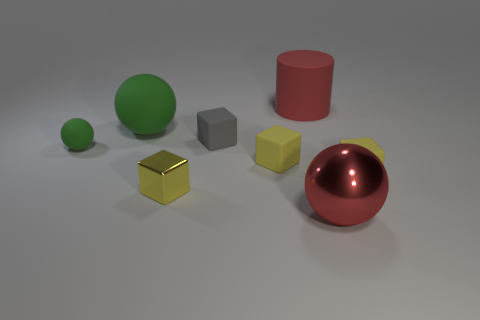What number of things are things that are behind the metallic block or tiny matte things? There are two items situated behind the metallic block: a green matte sphere and a red matte cylinder. As for the tiny matte objects, there is only one, a small grey cube. Therefore, combining both queries, the number of things behind the metallic block or tiny matte things totals to three. 